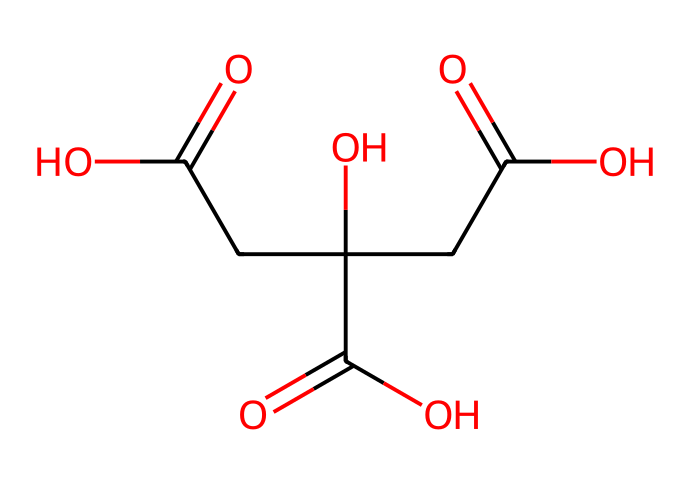What is the molecular formula of citric acid? To determine the molecular formula, we identify the number of each type of atom present in the SMILES representation. By analyzing the structure, we can count 6 carbon atoms, 8 hydrogen atoms, and 7 oxygen atoms, leading to the formula C6H8O7.
Answer: C6H8O7 How many carboxylic acid groups are present in citric acid? In the chemical structure, we can see that there are three -COOH groups, representing three carboxylic acid functional groups.
Answer: 3 What is the main functional group in citric acid? By inspecting the structure, we notice that the dominating feature is the carboxylic acid group (-COOH), which indicates that citric acid is classified as a carboxylic acid due to the presence of these functional groups.
Answer: carboxylic acid What property of citric acid allows it to act as a food preservative? The presence of multiple carboxylic acid groups in citric acid contributes to its ability to lower pH and inhibit microbial growth, thereby acting as a food preservative.
Answer: lowers pH How does citric acid contribute to the sour taste in foods? The sour taste of citric acid is attributed to its high acidity, which results from the release of hydrogen ions (H+) when the acid dissociates in solution. This leads to the perception of sourness on the taste buds.
Answer: acidity What is the total number of bonds present in citric acid's structure? To calculate the total number of bonds, we analyze the attachments in the chemical structure: each carbon atom forms a certain number of bonds which total to the overall connectivity. In this case, the total number of bonds comes to 12.
Answer: 12 